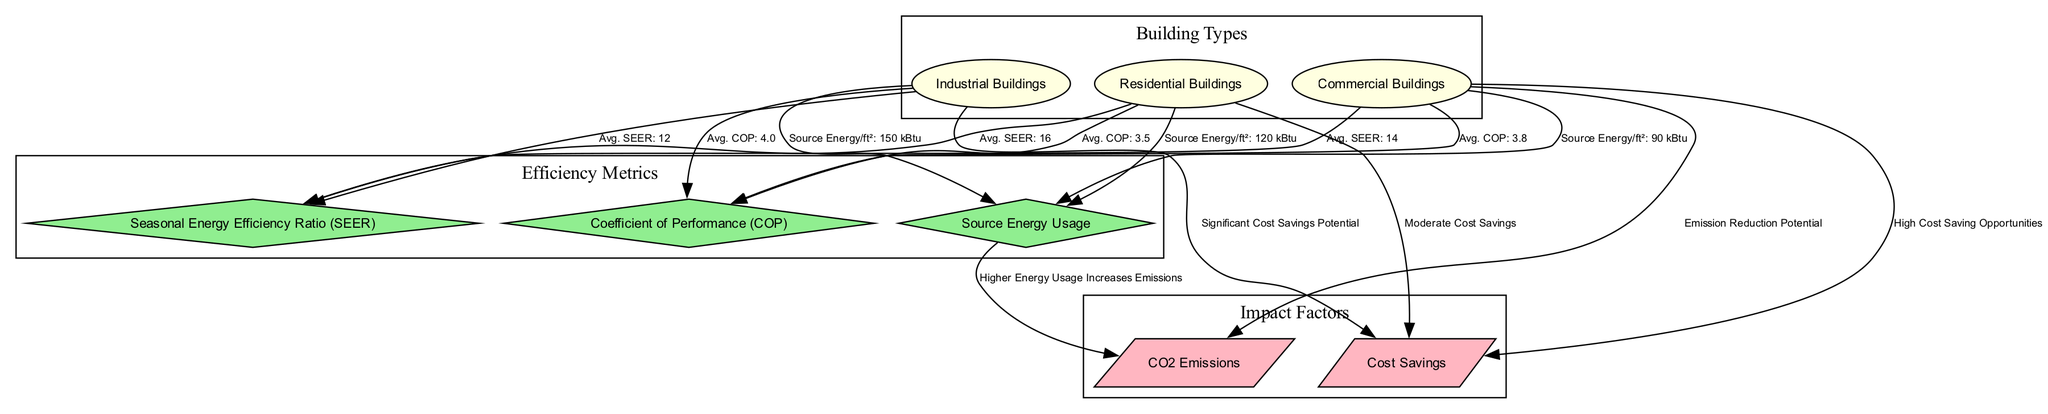What is the average SEER for Residential Buildings? The diagram shows a connection from the Residential Buildings node to the SEER node, indicating an average SEER of 16 for residential buildings.
Answer: 16 What is the average COP for Industrial Buildings? From the edges leading out from the Industrial Buildings node, the diagram indicates an average COP of 4.0.
Answer: 4.0 How many building types are represented in the diagram? The nodes for building types include Residential, Commercial, and Industrial. Therefore, there are three building types in total.
Answer: 3 Which building type has the highest average SEER? The edges indicate the average SEER values for each building type, with Residential Buildings showing the highest average SEER of 16.
Answer: Residential Buildings What impact does higher energy usage have on emissions? The relationship between source energy and emissions shows a direct statement: "Higher Energy Usage Increases Emissions." This indicates that increased energy usage correlates positively with emissions.
Answer: Increases Emissions Which building type has high cost-saving opportunities? The edge from the Commercial Buildings node to the cost-saving node highlights "High Cost Saving Opportunities," indicating that commercial buildings have the highest potential for cost savings.
Answer: Commercial Buildings What is the source energy usage per square foot for Commercial Buildings? The diagram connects Commercial Buildings to the source energy node, which shows an energy usage of 90 kBtu per square foot for commercial buildings.
Answer: 90 kBtu Which efficiency metric shows a significant savings potential for Industrial Buildings? The edge from Industrial Buildings to cost saving indicates "Significant Cost Savings Potential," suggesting that this efficiency metric stands out for industrial buildings.
Answer: Significant Cost Savings Potential What is the relationship shown between source energy and CO2 emissions? The connection indicates that there is a correlation where higher energy usage leads to increased emissions, thereby establishing how source energy affects CO2 emissions.
Answer: Higher Energy Usage Increases Emissions 